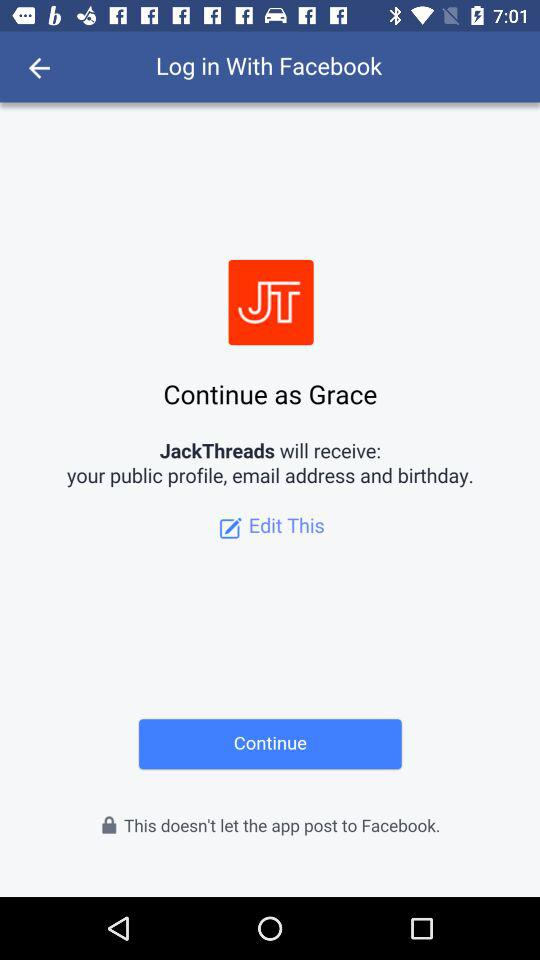Who will receive the public profile, birthday and email address? The application that will receive the public profile, birthday and email address is "JackThreads". 